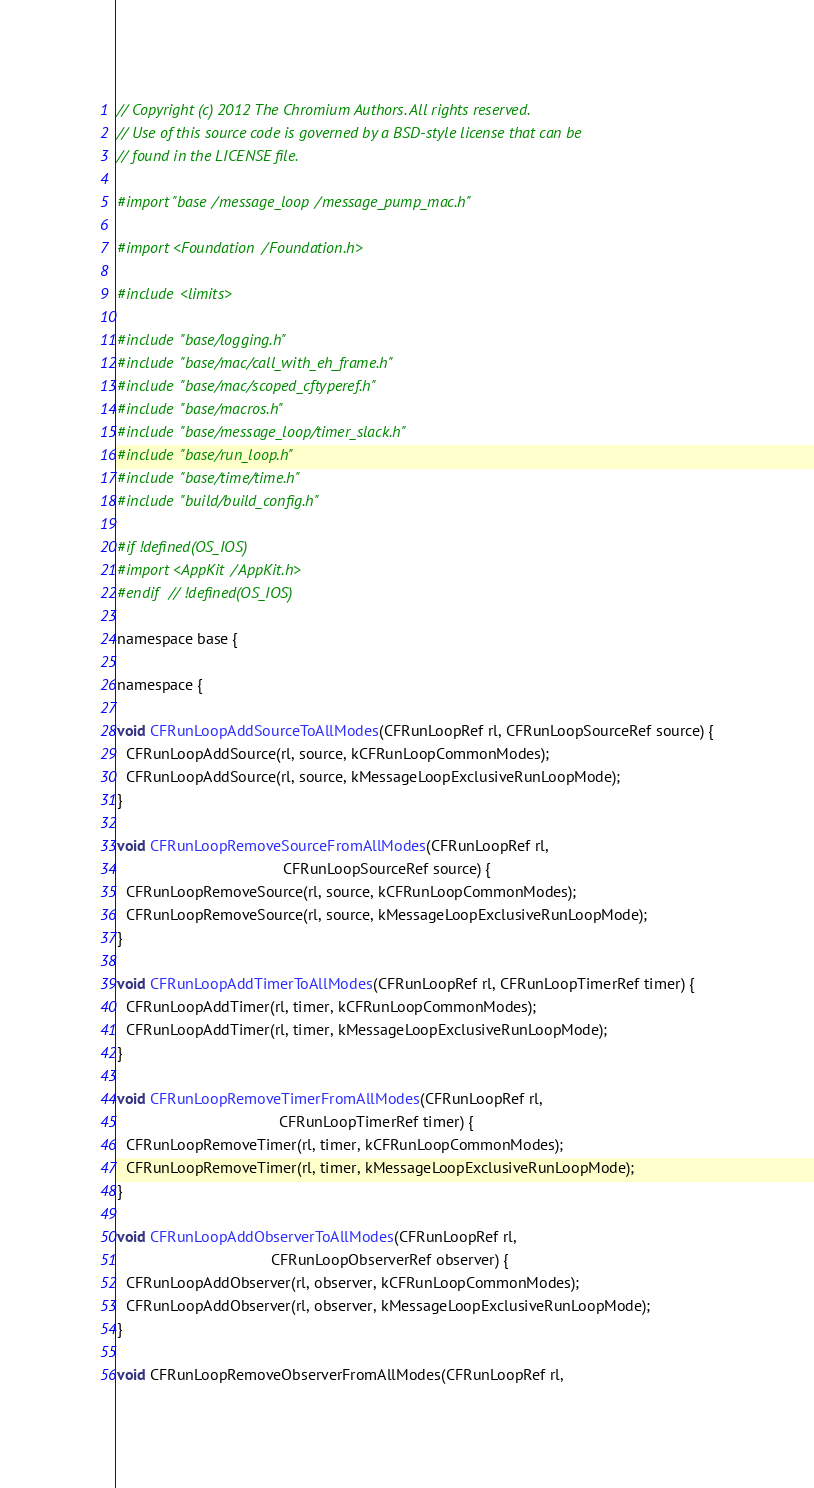<code> <loc_0><loc_0><loc_500><loc_500><_ObjectiveC_>// Copyright (c) 2012 The Chromium Authors. All rights reserved.
// Use of this source code is governed by a BSD-style license that can be
// found in the LICENSE file.

#import "base/message_loop/message_pump_mac.h"

#import <Foundation/Foundation.h>

#include <limits>

#include "base/logging.h"
#include "base/mac/call_with_eh_frame.h"
#include "base/mac/scoped_cftyperef.h"
#include "base/macros.h"
#include "base/message_loop/timer_slack.h"
#include "base/run_loop.h"
#include "base/time/time.h"
#include "build/build_config.h"

#if !defined(OS_IOS)
#import <AppKit/AppKit.h>
#endif  // !defined(OS_IOS)

namespace base {

namespace {

void CFRunLoopAddSourceToAllModes(CFRunLoopRef rl, CFRunLoopSourceRef source) {
  CFRunLoopAddSource(rl, source, kCFRunLoopCommonModes);
  CFRunLoopAddSource(rl, source, kMessageLoopExclusiveRunLoopMode);
}

void CFRunLoopRemoveSourceFromAllModes(CFRunLoopRef rl,
                                       CFRunLoopSourceRef source) {
  CFRunLoopRemoveSource(rl, source, kCFRunLoopCommonModes);
  CFRunLoopRemoveSource(rl, source, kMessageLoopExclusiveRunLoopMode);
}

void CFRunLoopAddTimerToAllModes(CFRunLoopRef rl, CFRunLoopTimerRef timer) {
  CFRunLoopAddTimer(rl, timer, kCFRunLoopCommonModes);
  CFRunLoopAddTimer(rl, timer, kMessageLoopExclusiveRunLoopMode);
}

void CFRunLoopRemoveTimerFromAllModes(CFRunLoopRef rl,
                                      CFRunLoopTimerRef timer) {
  CFRunLoopRemoveTimer(rl, timer, kCFRunLoopCommonModes);
  CFRunLoopRemoveTimer(rl, timer, kMessageLoopExclusiveRunLoopMode);
}

void CFRunLoopAddObserverToAllModes(CFRunLoopRef rl,
                                    CFRunLoopObserverRef observer) {
  CFRunLoopAddObserver(rl, observer, kCFRunLoopCommonModes);
  CFRunLoopAddObserver(rl, observer, kMessageLoopExclusiveRunLoopMode);
}

void CFRunLoopRemoveObserverFromAllModes(CFRunLoopRef rl,</code> 